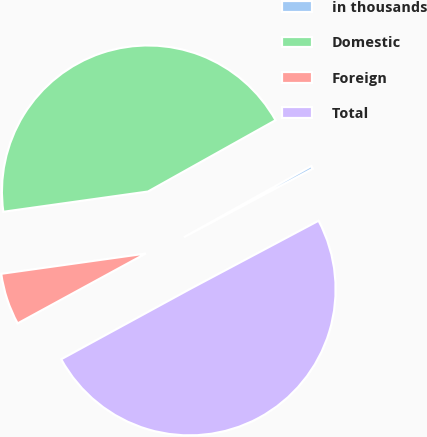Convert chart to OTSL. <chart><loc_0><loc_0><loc_500><loc_500><pie_chart><fcel>in thousands<fcel>Domestic<fcel>Foreign<fcel>Total<nl><fcel>0.34%<fcel>44.1%<fcel>5.73%<fcel>49.83%<nl></chart> 